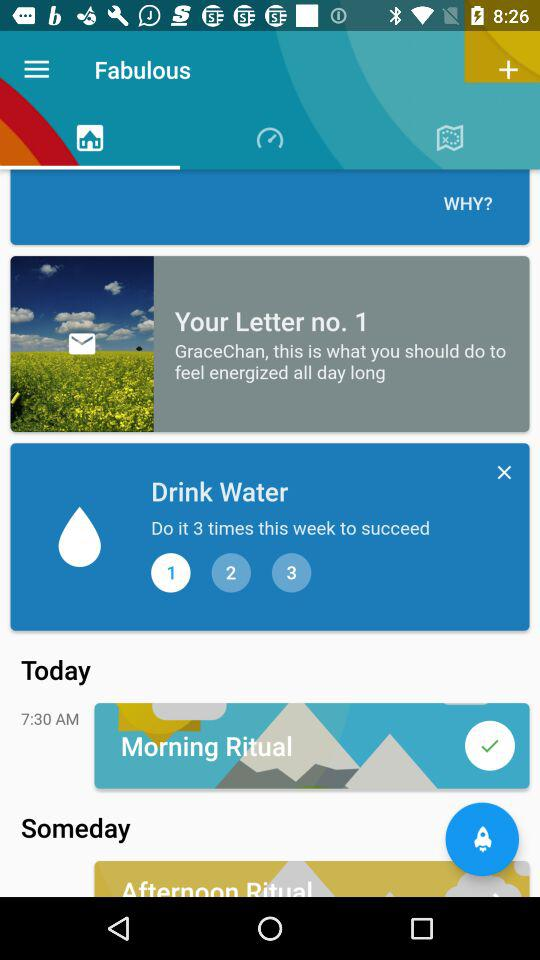What time is the morning ritual scheduled for?
Answer the question using a single word or phrase. 7:30 AM 